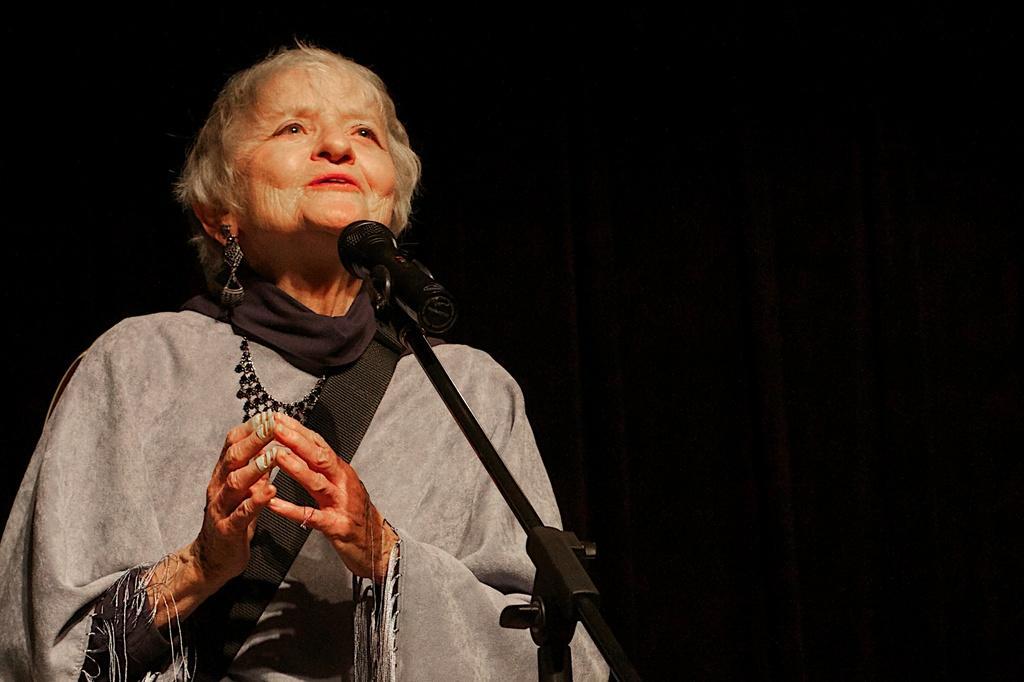Describe this image in one or two sentences. In this picture we can see a woman, she is standing in front of microphone. 